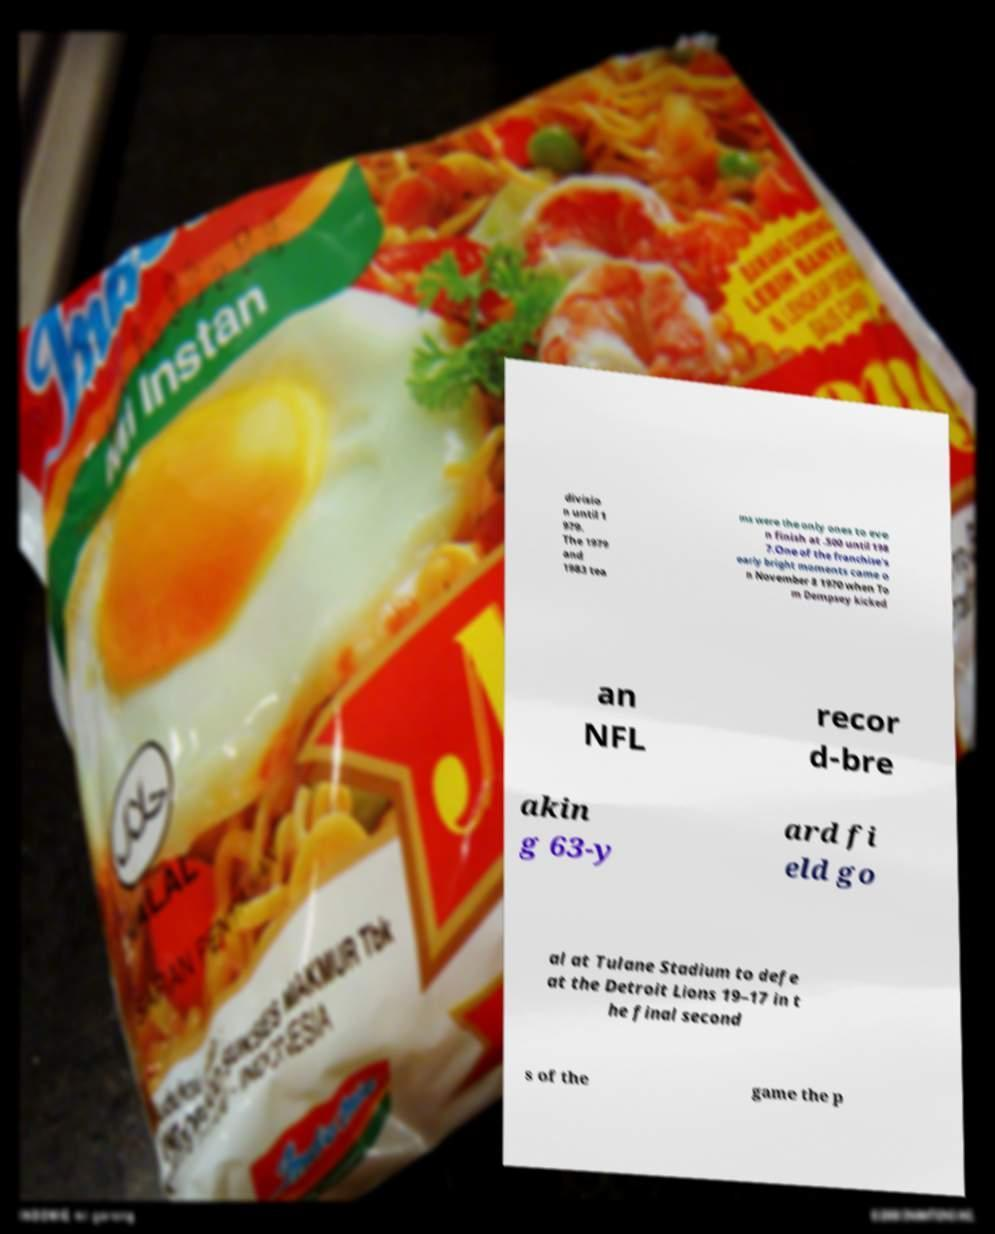What messages or text are displayed in this image? I need them in a readable, typed format. divisio n until 1 979. The 1979 and 1983 tea ms were the only ones to eve n finish at .500 until 198 7.One of the franchise's early bright moments came o n November 8 1970 when To m Dempsey kicked an NFL recor d-bre akin g 63-y ard fi eld go al at Tulane Stadium to defe at the Detroit Lions 19–17 in t he final second s of the game the p 